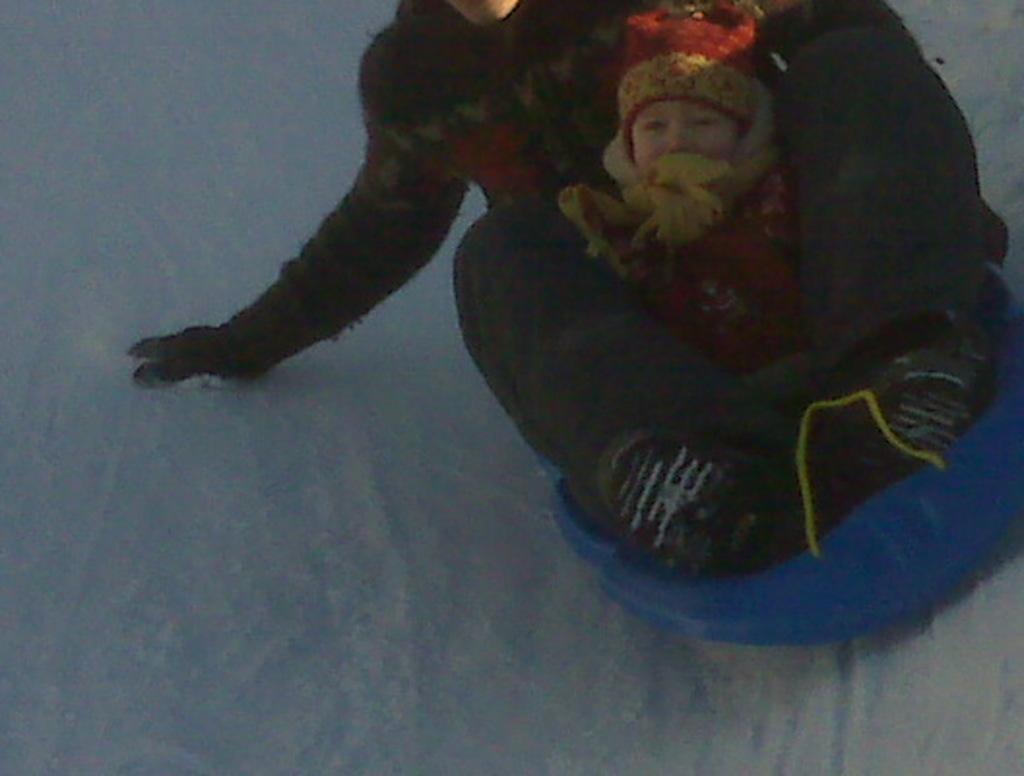Please provide a concise description of this image. In the image there is a person with a baby sliding on snow. they both wore woolen clothes. 